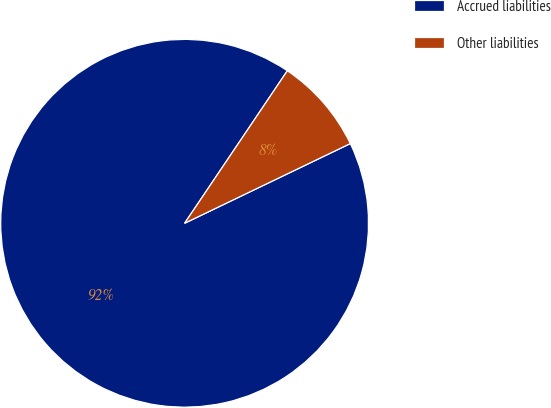Convert chart to OTSL. <chart><loc_0><loc_0><loc_500><loc_500><pie_chart><fcel>Accrued liabilities<fcel>Other liabilities<nl><fcel>91.57%<fcel>8.43%<nl></chart> 